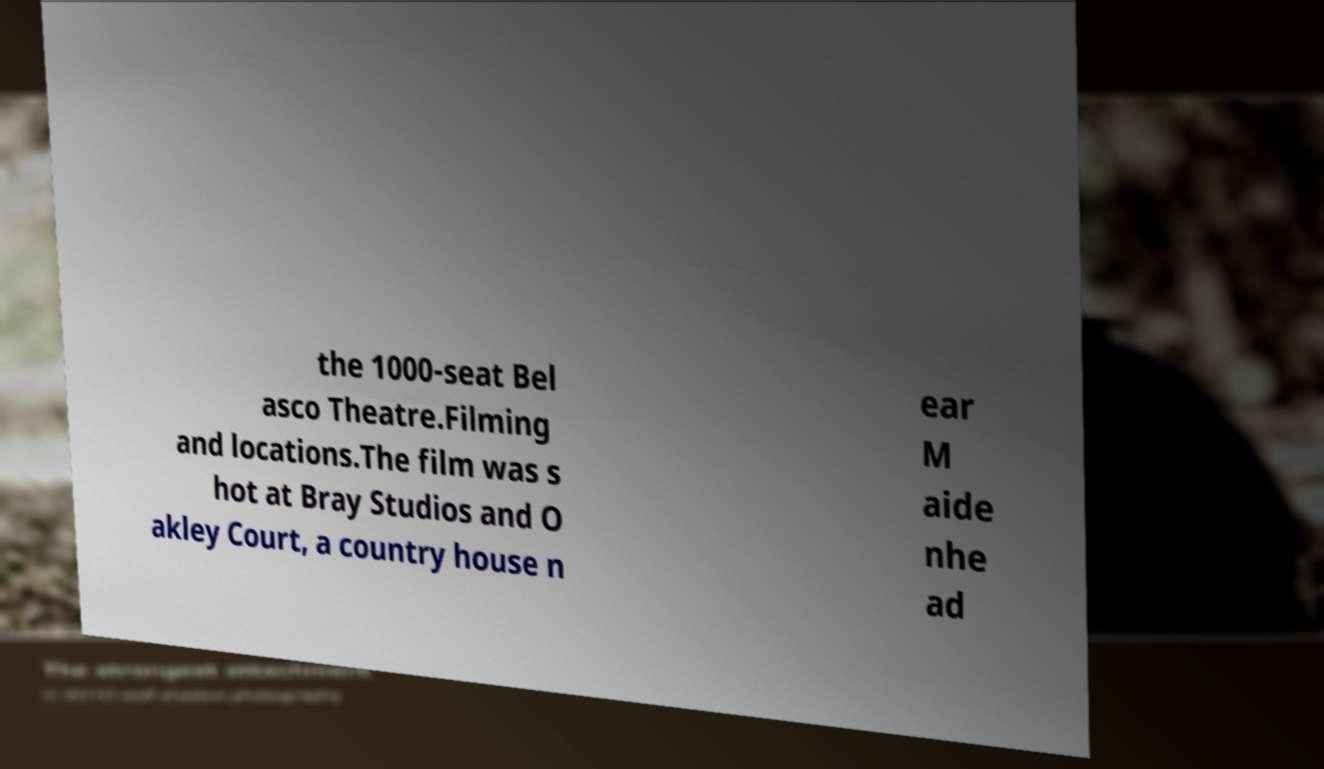There's text embedded in this image that I need extracted. Can you transcribe it verbatim? the 1000-seat Bel asco Theatre.Filming and locations.The film was s hot at Bray Studios and O akley Court, a country house n ear M aide nhe ad 